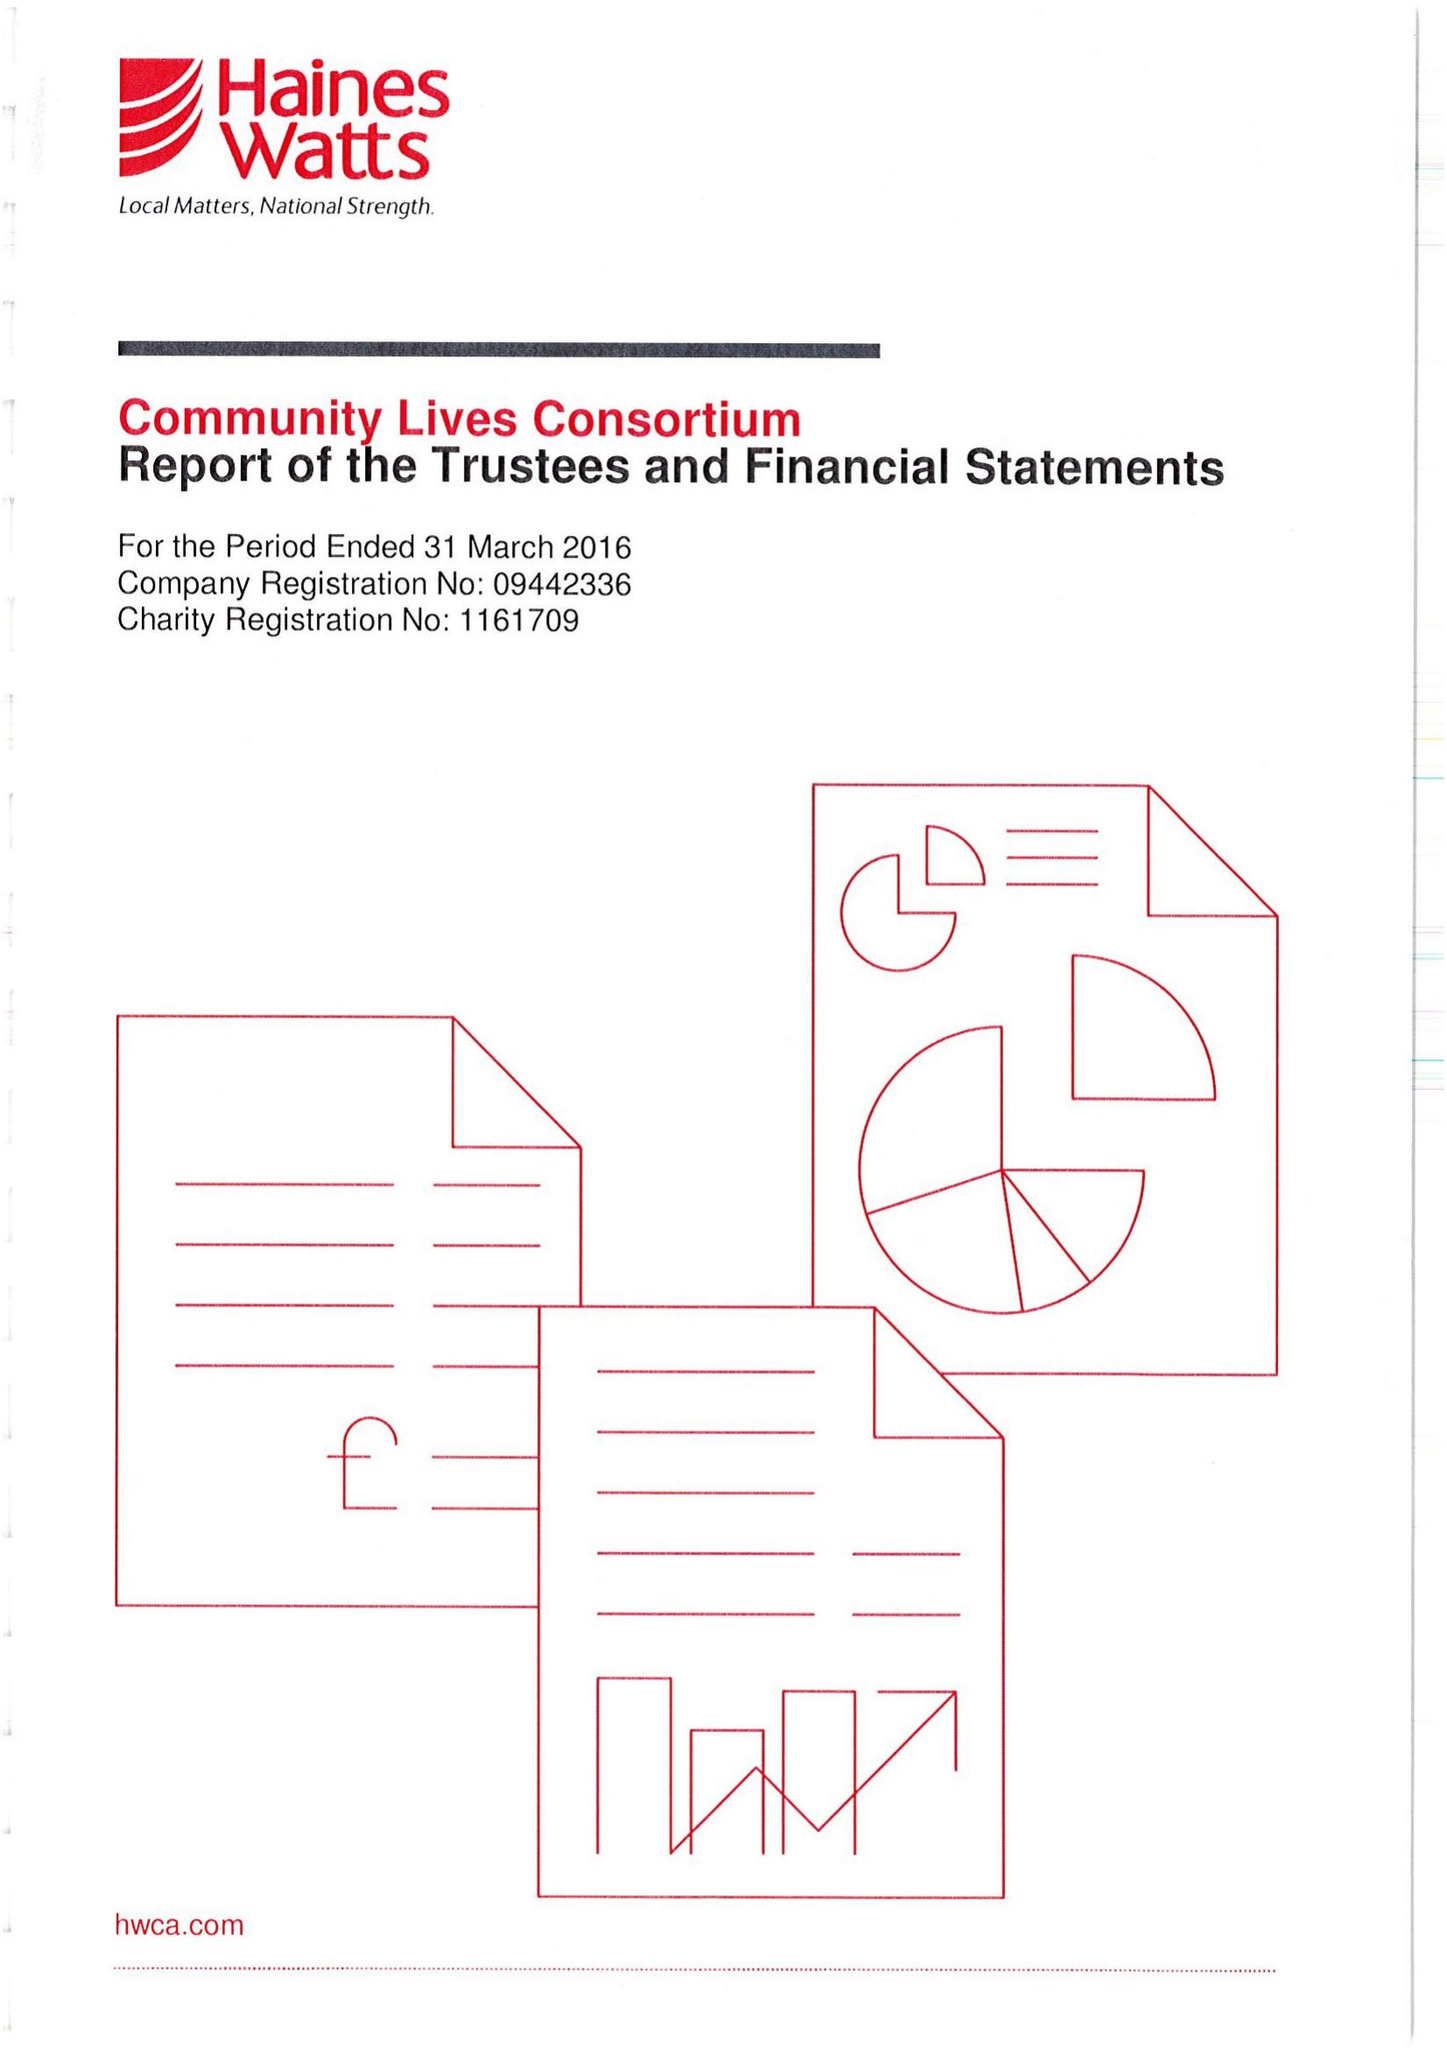What is the value for the charity_name?
Answer the question using a single word or phrase. Community Lives Consortium 